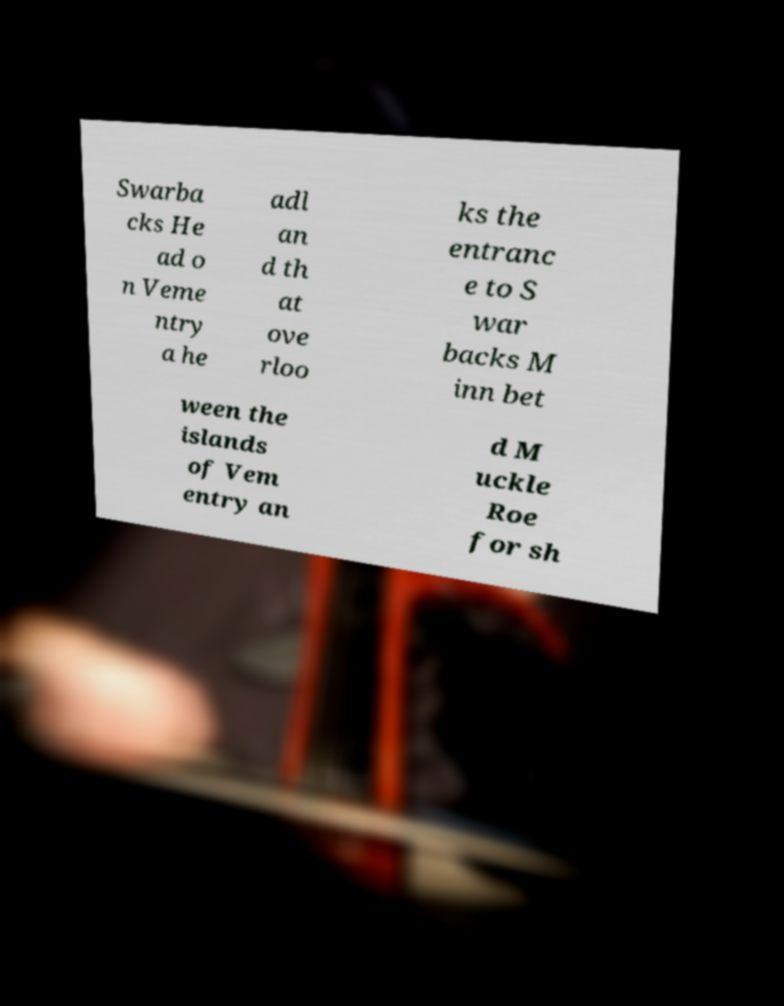I need the written content from this picture converted into text. Can you do that? Swarba cks He ad o n Veme ntry a he adl an d th at ove rloo ks the entranc e to S war backs M inn bet ween the islands of Vem entry an d M uckle Roe for sh 